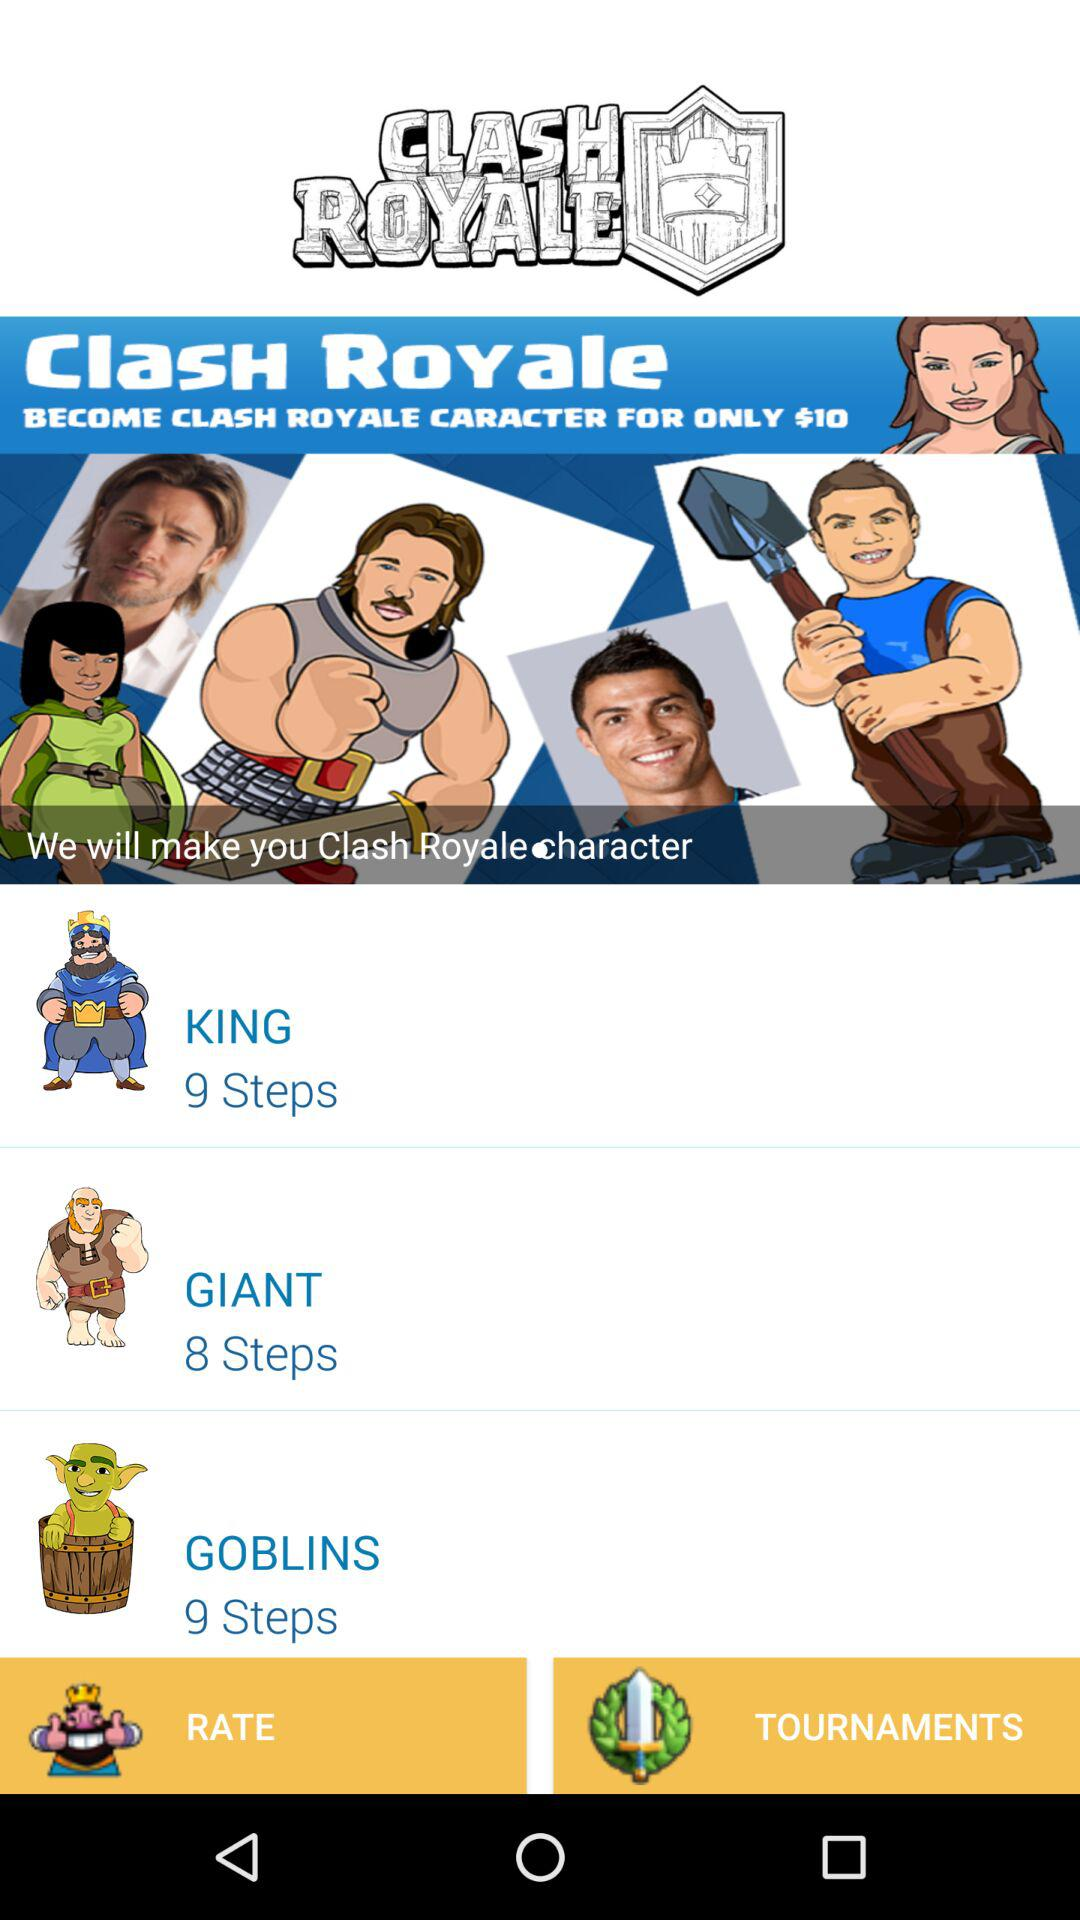What is the count of steps for "GIANT"? The count of steps for "GIANT" is 8. 